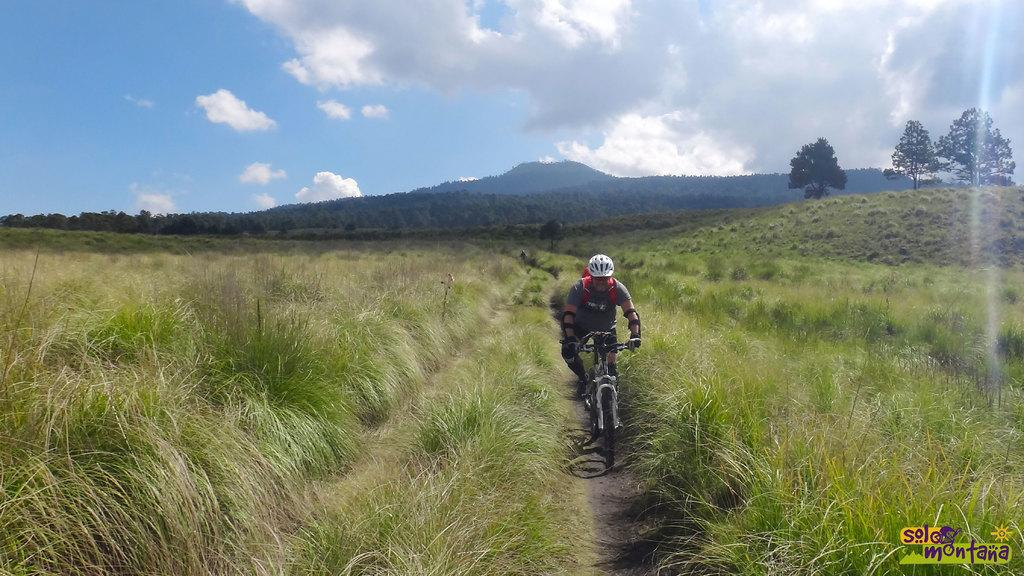What is the person in the image doing? There is a person riding a bicycle in the image. What can be seen on either side of the person? There is green grass on either side of the person. What is visible in the background of the image? There are trees and mountains in the background. What type of cart is being pulled by the person riding the bicycle in the image? There is no cart being pulled by the person riding the bicycle in the image. What activity is the person wearing trousers engaged in? The provided facts do not mention the person's attire, so we cannot determine if they are wearing trousers or what activity they might be engaged in. 